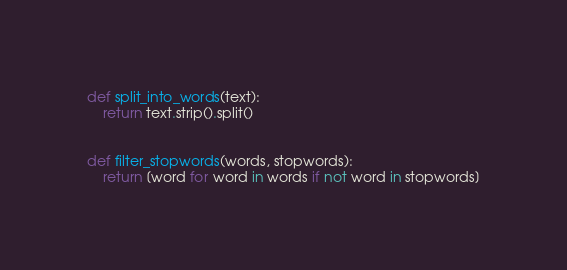Convert code to text. <code><loc_0><loc_0><loc_500><loc_500><_Python_>def split_into_words(text):
    return text.strip().split()


def filter_stopwords(words, stopwords):
    return [word for word in words if not word in stopwords]</code> 